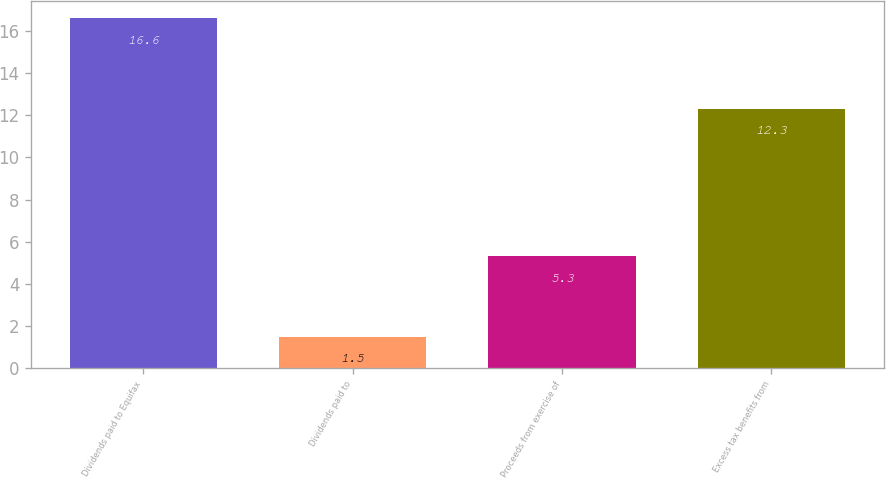<chart> <loc_0><loc_0><loc_500><loc_500><bar_chart><fcel>Dividends paid to Equifax<fcel>Dividends paid to<fcel>Proceeds from exercise of<fcel>Excess tax benefits from<nl><fcel>16.6<fcel>1.5<fcel>5.3<fcel>12.3<nl></chart> 